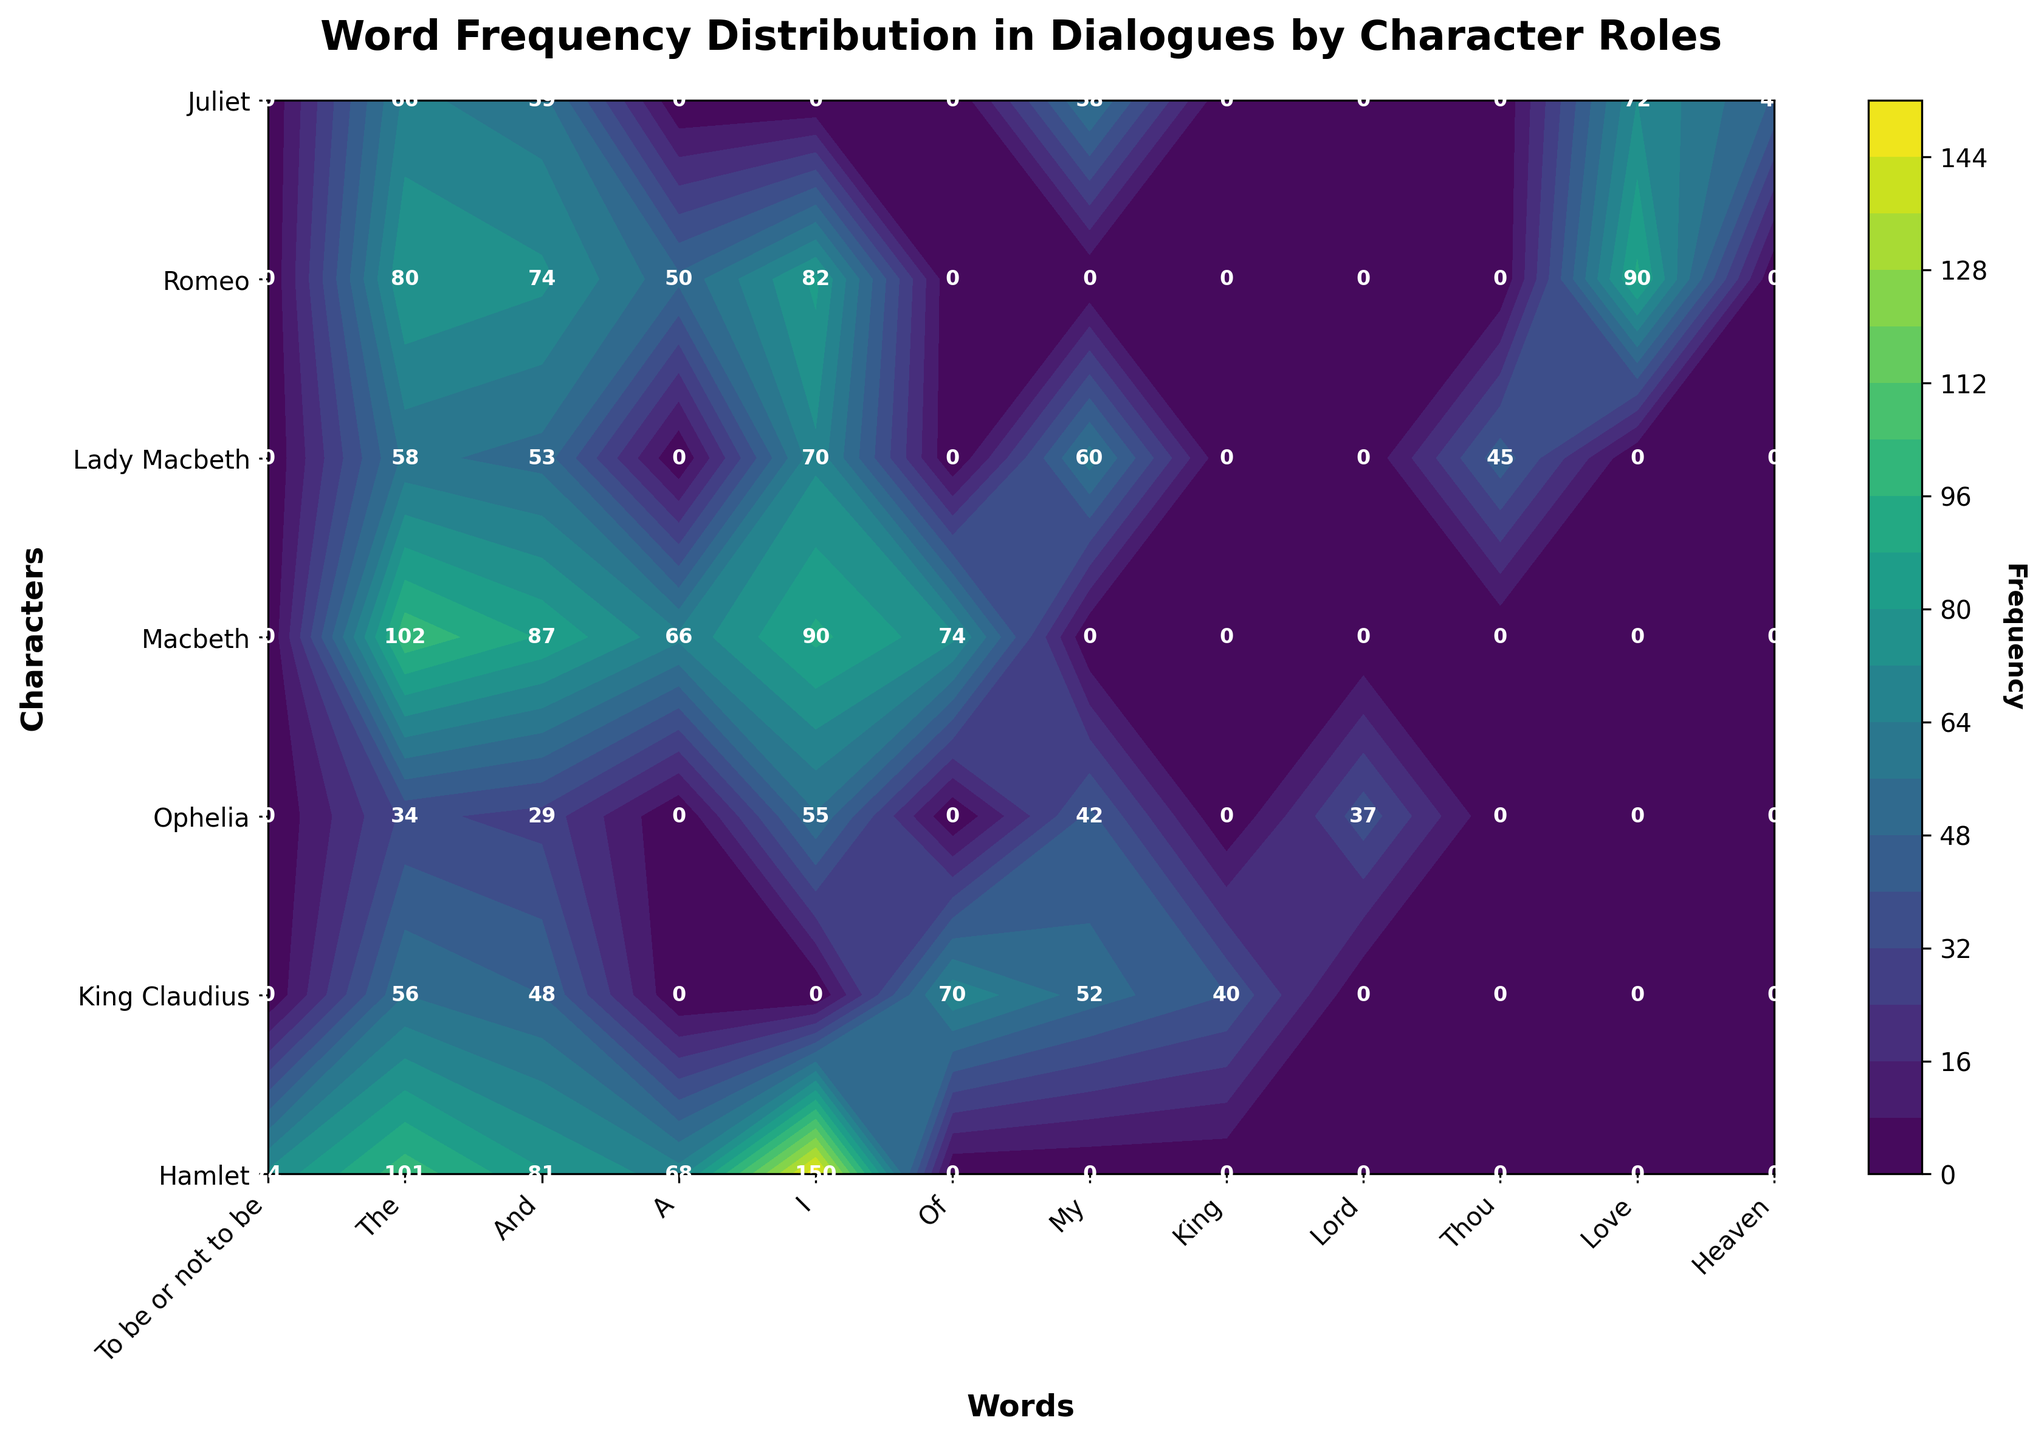What is the title of the figure? The title of the figure is located at the top. By reading it, you can determine the overall topic of the figure.
Answer: Word Frequency Distribution in Dialogues by Character Roles Which character uses the word "I" the most? Look at the contour plot, find the row corresponding to each character, then find the column for the word "I". The character with the highest frequency value for "I" uses it the most.
Answer: Hamlet What is the frequency of the word "Love" for Romeo compared to Juliet? Locate the rows for Romeo and Juliet and the column for "Love". Read the frequency values and compare them.
Answer: Romeo: 90, Juliet: 72 How many characters have a frequency of at least 80 for the word "The"? Look at the column for "The" and count the rows where the frequency is 80 or higher.
Answer: Three characters Which word does King Claudius use the least frequently based on the figure? Find the row corresponding to King Claudius and look for the word with the lowest frequency marked on the plot.
Answer: King Among the characters Hamlet and Macbeth, who uses the word "And" more frequently, and by how much? Find the row corresponding to Hamlet and Macbeth, then look at the column for "And". Subtract Macbeth's frequency from Hamlet's frequency for the word "And".
Answer: Hamlet by 6 What is the average frequency of the word "My" used by all characters combined? Sum up the frequencies of "My" for all characters and then divide by the number of characters.
Answer: The average is 52.67 What can you infer about the use of the word "Lord" in terms of characters? Look at the column for "Lord" and observe which characters use it and their frequencies.
Answer: Only Ophelia uses "Lord" with a frequency of 37 Which character's word usage has the highest frequency value in the plot, and what is that value? Scan the entire contour plot for the highest frequency value and identify the corresponding character.
Answer: Hamlet, frequency of 150 Do any characters have the same frequency for the word "A"? If so, who? Look at the column for "A" and compare the frequency values across all characters.
Answer: Hamlet and Macbeth both have 68 